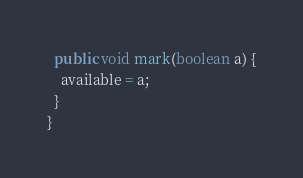<code> <loc_0><loc_0><loc_500><loc_500><_Java_>  public void mark(boolean a) {
    available = a;
  }
}
</code> 